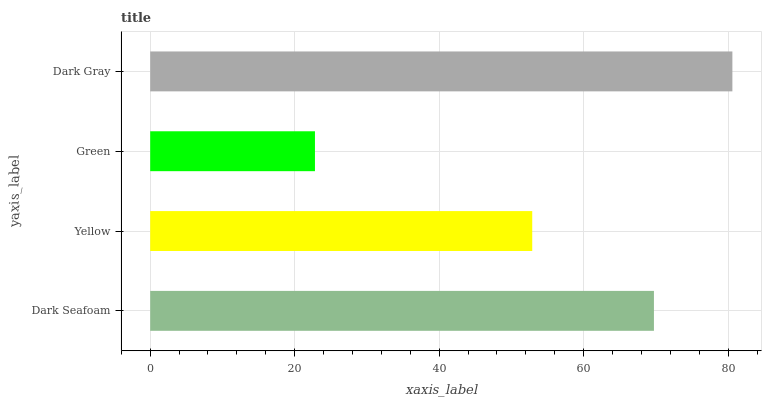Is Green the minimum?
Answer yes or no. Yes. Is Dark Gray the maximum?
Answer yes or no. Yes. Is Yellow the minimum?
Answer yes or no. No. Is Yellow the maximum?
Answer yes or no. No. Is Dark Seafoam greater than Yellow?
Answer yes or no. Yes. Is Yellow less than Dark Seafoam?
Answer yes or no. Yes. Is Yellow greater than Dark Seafoam?
Answer yes or no. No. Is Dark Seafoam less than Yellow?
Answer yes or no. No. Is Dark Seafoam the high median?
Answer yes or no. Yes. Is Yellow the low median?
Answer yes or no. Yes. Is Yellow the high median?
Answer yes or no. No. Is Dark Gray the low median?
Answer yes or no. No. 